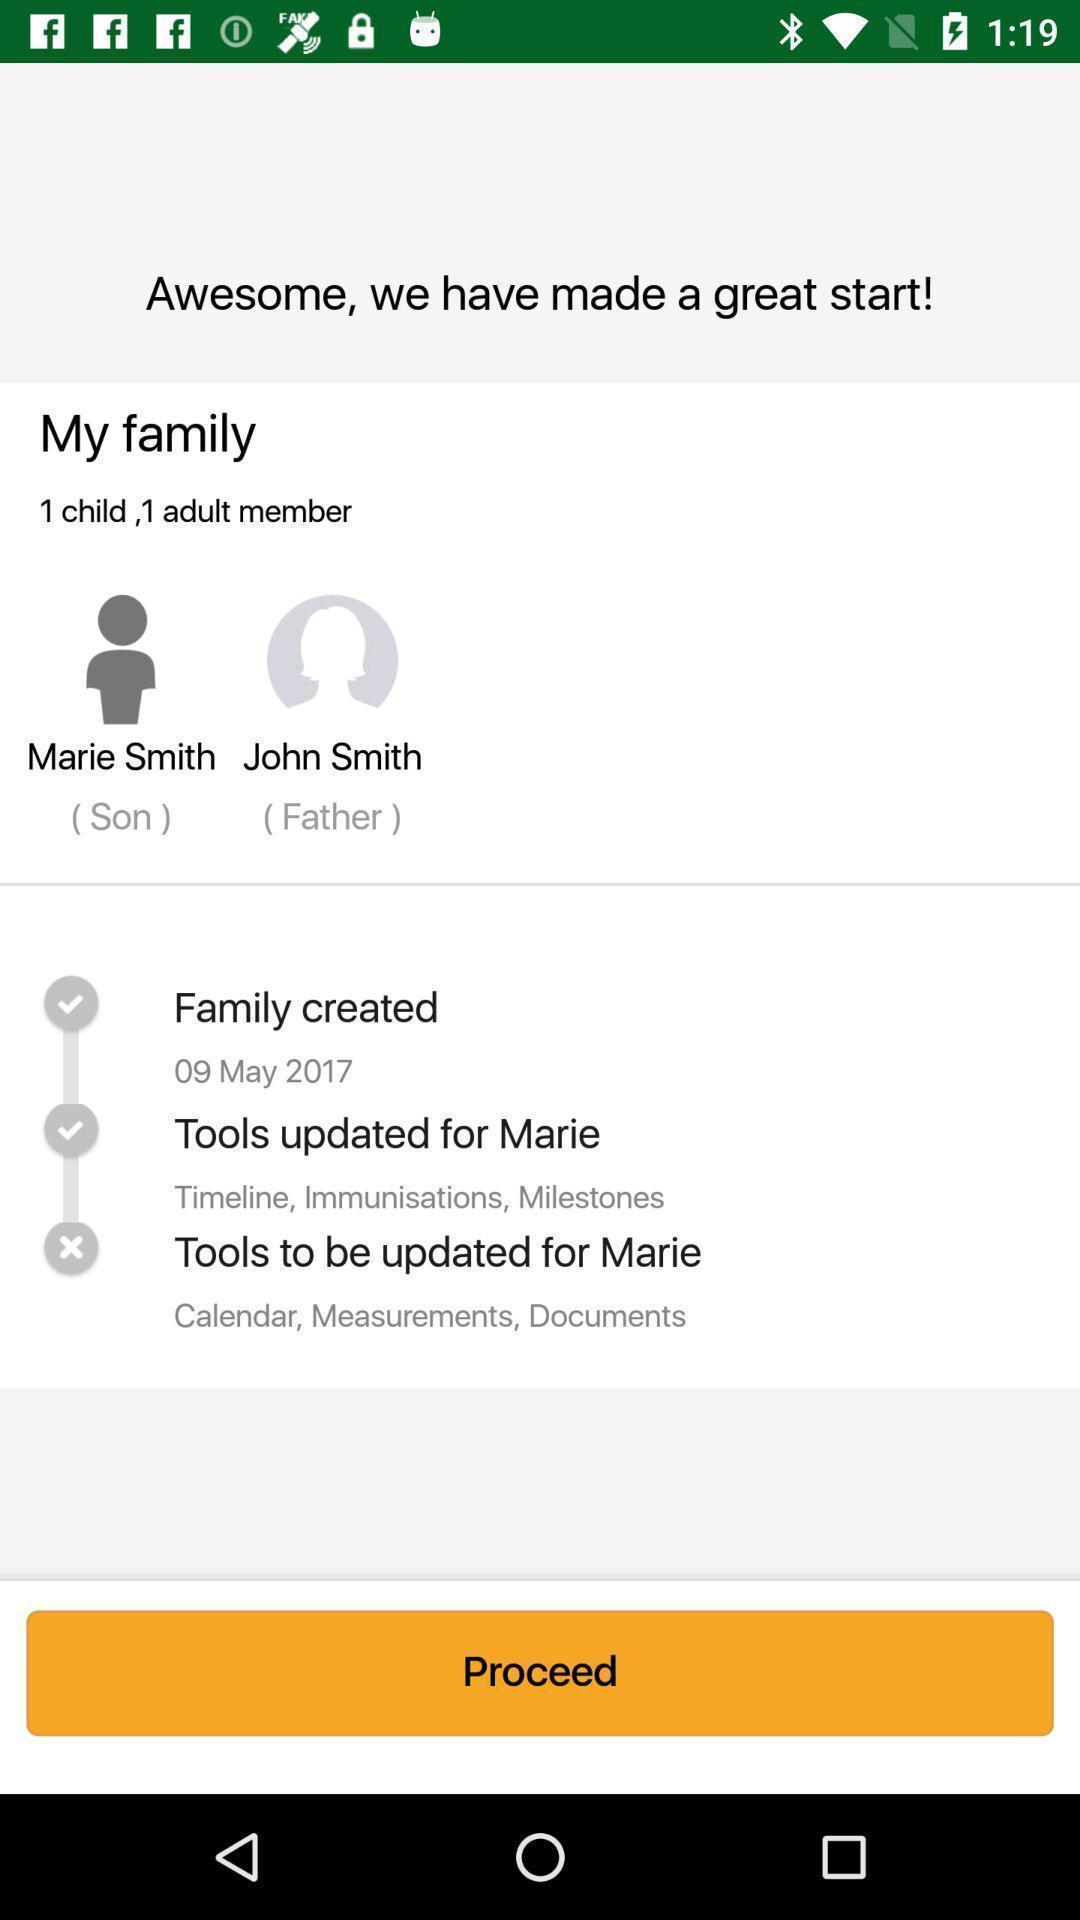Give me a narrative description of this picture. Screen displaying users information and other options. 